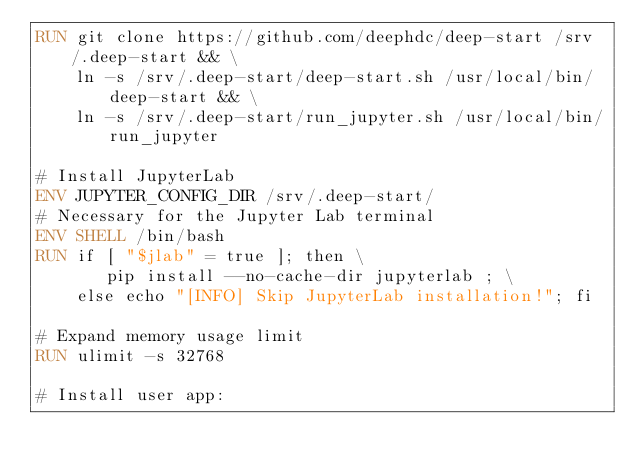<code> <loc_0><loc_0><loc_500><loc_500><_Dockerfile_>RUN git clone https://github.com/deephdc/deep-start /srv/.deep-start && \
    ln -s /srv/.deep-start/deep-start.sh /usr/local/bin/deep-start && \
    ln -s /srv/.deep-start/run_jupyter.sh /usr/local/bin/run_jupyter

# Install JupyterLab
ENV JUPYTER_CONFIG_DIR /srv/.deep-start/
# Necessary for the Jupyter Lab terminal
ENV SHELL /bin/bash
RUN if [ "$jlab" = true ]; then \
       pip install --no-cache-dir jupyterlab ; \
    else echo "[INFO] Skip JupyterLab installation!"; fi

# Expand memory usage limit
RUN ulimit -s 32768

# Install user app:</code> 